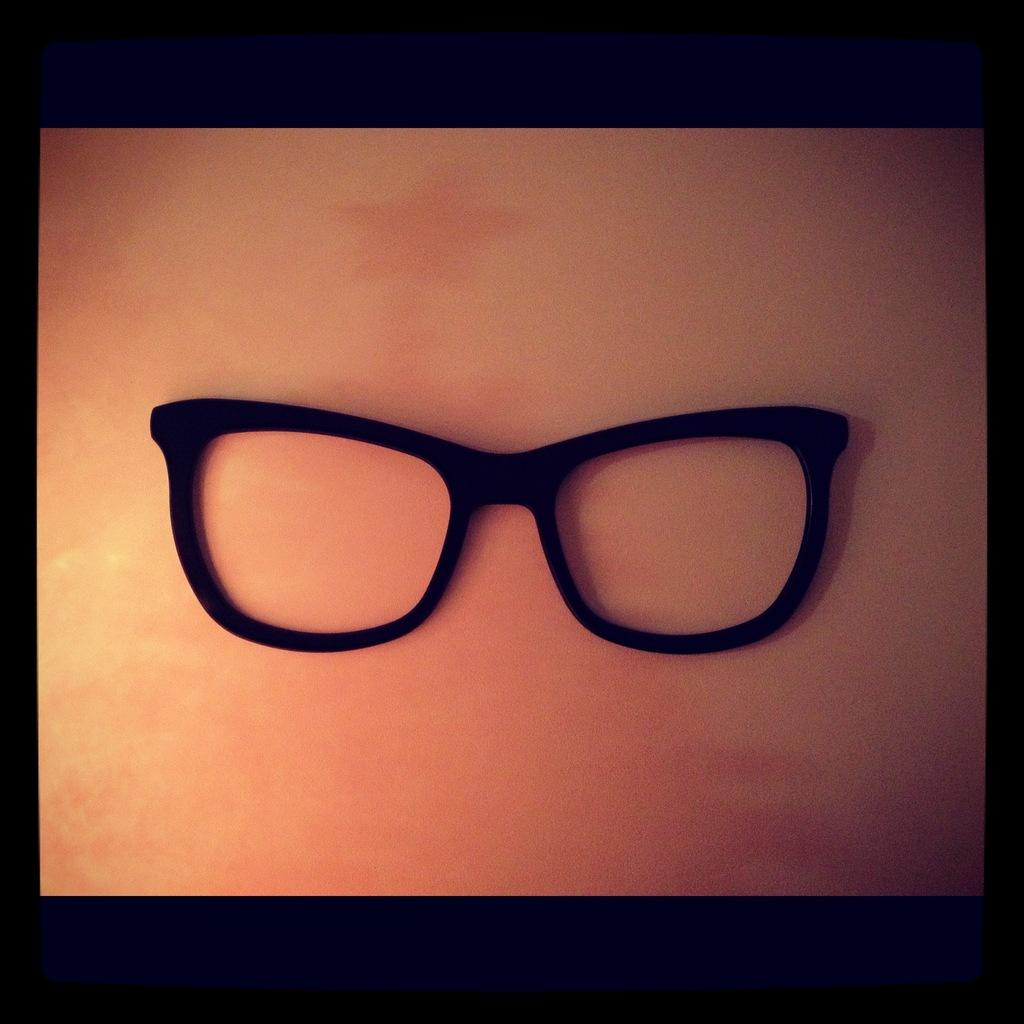What object is the main focus of the image? The main focus of the image is a spectacle frame. What color is the background of the image? The background of the image is light brown. How many friends are playing with the ball in the image? There is no ball or friends present in the image; it only features a spectacle frame. What type of spade is being used to dig in the image? There is no spade or digging activity present in the image. 